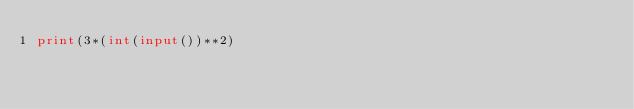<code> <loc_0><loc_0><loc_500><loc_500><_Python_>print(3*(int(input())**2)</code> 